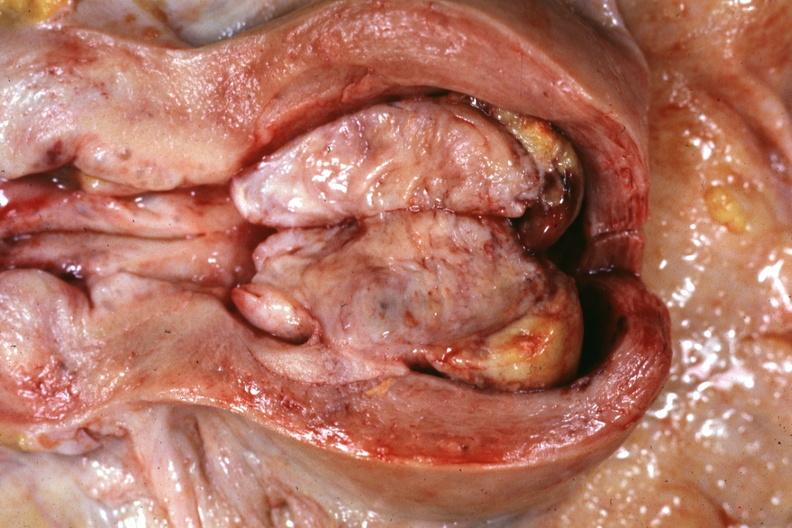where does this part belong to?
Answer the question using a single word or phrase. Female reproductive system 